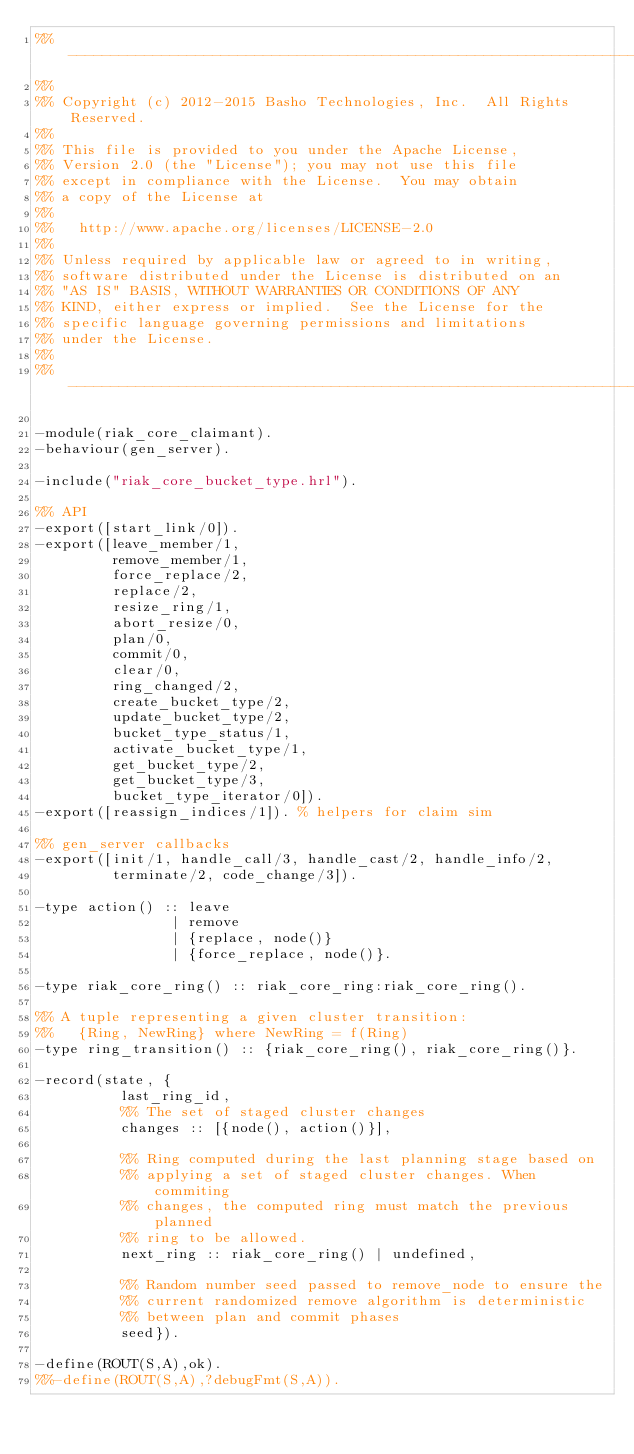Convert code to text. <code><loc_0><loc_0><loc_500><loc_500><_Erlang_>%% -------------------------------------------------------------------
%%
%% Copyright (c) 2012-2015 Basho Technologies, Inc.  All Rights Reserved.
%%
%% This file is provided to you under the Apache License,
%% Version 2.0 (the "License"); you may not use this file
%% except in compliance with the License.  You may obtain
%% a copy of the License at
%%
%%   http://www.apache.org/licenses/LICENSE-2.0
%%
%% Unless required by applicable law or agreed to in writing,
%% software distributed under the License is distributed on an
%% "AS IS" BASIS, WITHOUT WARRANTIES OR CONDITIONS OF ANY
%% KIND, either express or implied.  See the License for the
%% specific language governing permissions and limitations
%% under the License.
%%
%% -------------------------------------------------------------------

-module(riak_core_claimant).
-behaviour(gen_server).

-include("riak_core_bucket_type.hrl").

%% API
-export([start_link/0]).
-export([leave_member/1,
         remove_member/1,
         force_replace/2,
         replace/2,
         resize_ring/1,
         abort_resize/0,
         plan/0,
         commit/0,
         clear/0,
         ring_changed/2,
         create_bucket_type/2,
         update_bucket_type/2,
         bucket_type_status/1,
         activate_bucket_type/1,
         get_bucket_type/2,
         get_bucket_type/3,
         bucket_type_iterator/0]).
-export([reassign_indices/1]). % helpers for claim sim

%% gen_server callbacks
-export([init/1, handle_call/3, handle_cast/2, handle_info/2,
         terminate/2, code_change/3]).

-type action() :: leave
                | remove
                | {replace, node()}
                | {force_replace, node()}.

-type riak_core_ring() :: riak_core_ring:riak_core_ring().

%% A tuple representing a given cluster transition:
%%   {Ring, NewRing} where NewRing = f(Ring)
-type ring_transition() :: {riak_core_ring(), riak_core_ring()}.

-record(state, {
          last_ring_id,
          %% The set of staged cluster changes
          changes :: [{node(), action()}],

          %% Ring computed during the last planning stage based on
          %% applying a set of staged cluster changes. When commiting
          %% changes, the computed ring must match the previous planned
          %% ring to be allowed.
          next_ring :: riak_core_ring() | undefined,

          %% Random number seed passed to remove_node to ensure the
          %% current randomized remove algorithm is deterministic
          %% between plan and commit phases
          seed}).

-define(ROUT(S,A),ok).
%%-define(ROUT(S,A),?debugFmt(S,A)).</code> 